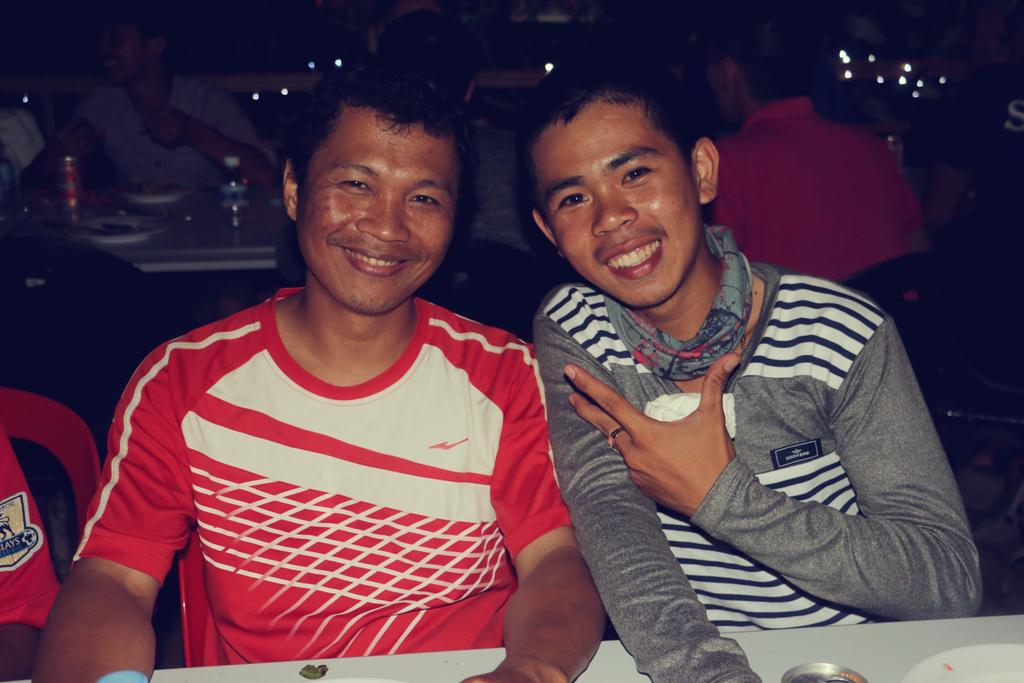What are the people in the image doing? The people in the image are sitting on chairs. What is located at the center of the image? There is a table at the center of the image. What objects can be seen on the table? There is a bottle, plates, and a tin on the table. How fast is the bear running in the image? There is no bear present in the image, so it is not possible to determine its speed. 